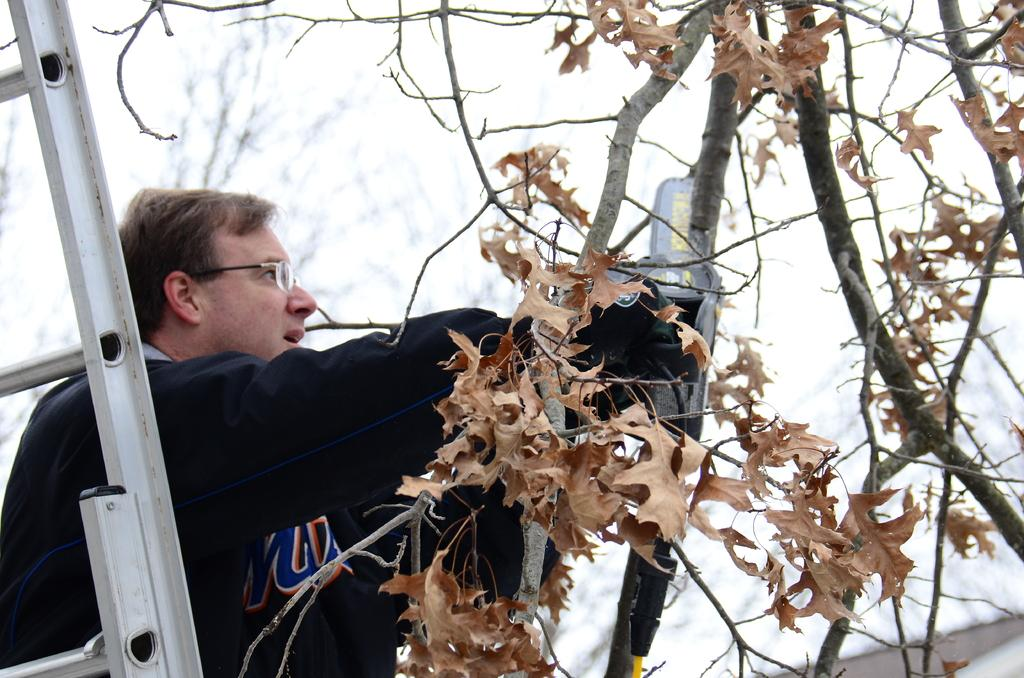Who is present in the image? There is a man in the image. What is the man standing near? The man is standing in front of a ladder and beside a tree. What is the man holding in the image? The man is holding something. What type of chair is the man sitting on in the image? There is no chair present in the image; the man is standing. What is the man using to sew in the image? There is no needle or sewing activity depicted in the image. 